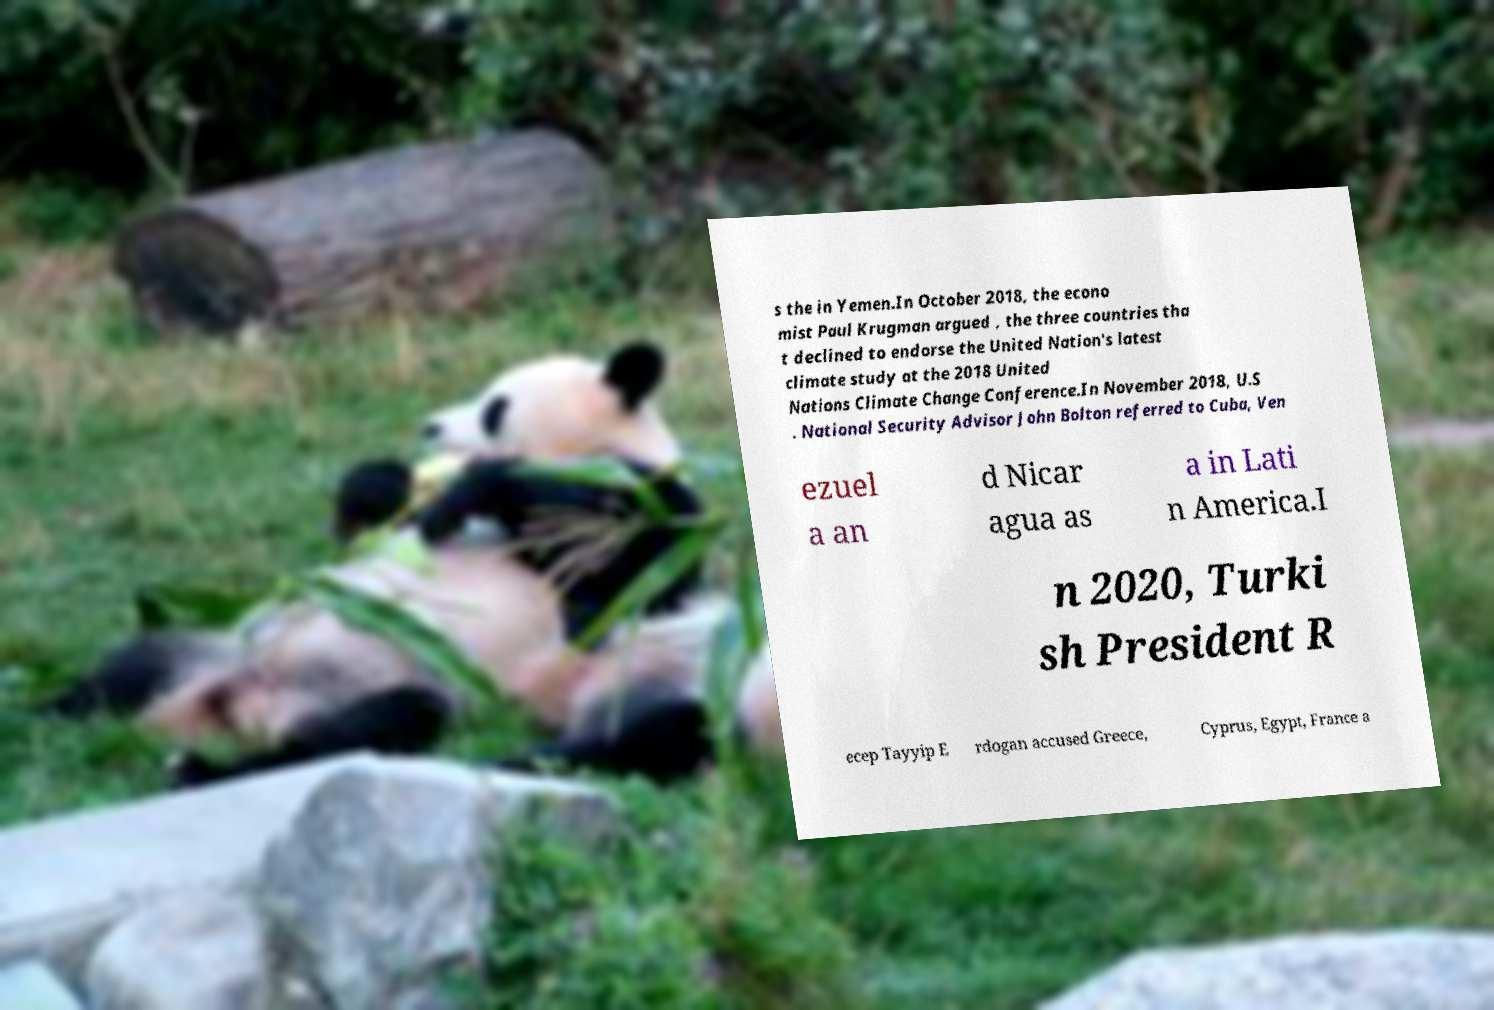Please identify and transcribe the text found in this image. s the in Yemen.In October 2018, the econo mist Paul Krugman argued , the three countries tha t declined to endorse the United Nation's latest climate study at the 2018 United Nations Climate Change Conference.In November 2018, U.S . National Security Advisor John Bolton referred to Cuba, Ven ezuel a an d Nicar agua as a in Lati n America.I n 2020, Turki sh President R ecep Tayyip E rdogan accused Greece, Cyprus, Egypt, France a 